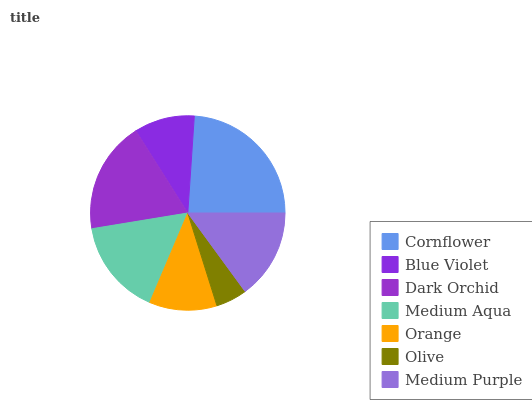Is Olive the minimum?
Answer yes or no. Yes. Is Cornflower the maximum?
Answer yes or no. Yes. Is Blue Violet the minimum?
Answer yes or no. No. Is Blue Violet the maximum?
Answer yes or no. No. Is Cornflower greater than Blue Violet?
Answer yes or no. Yes. Is Blue Violet less than Cornflower?
Answer yes or no. Yes. Is Blue Violet greater than Cornflower?
Answer yes or no. No. Is Cornflower less than Blue Violet?
Answer yes or no. No. Is Medium Purple the high median?
Answer yes or no. Yes. Is Medium Purple the low median?
Answer yes or no. Yes. Is Orange the high median?
Answer yes or no. No. Is Dark Orchid the low median?
Answer yes or no. No. 